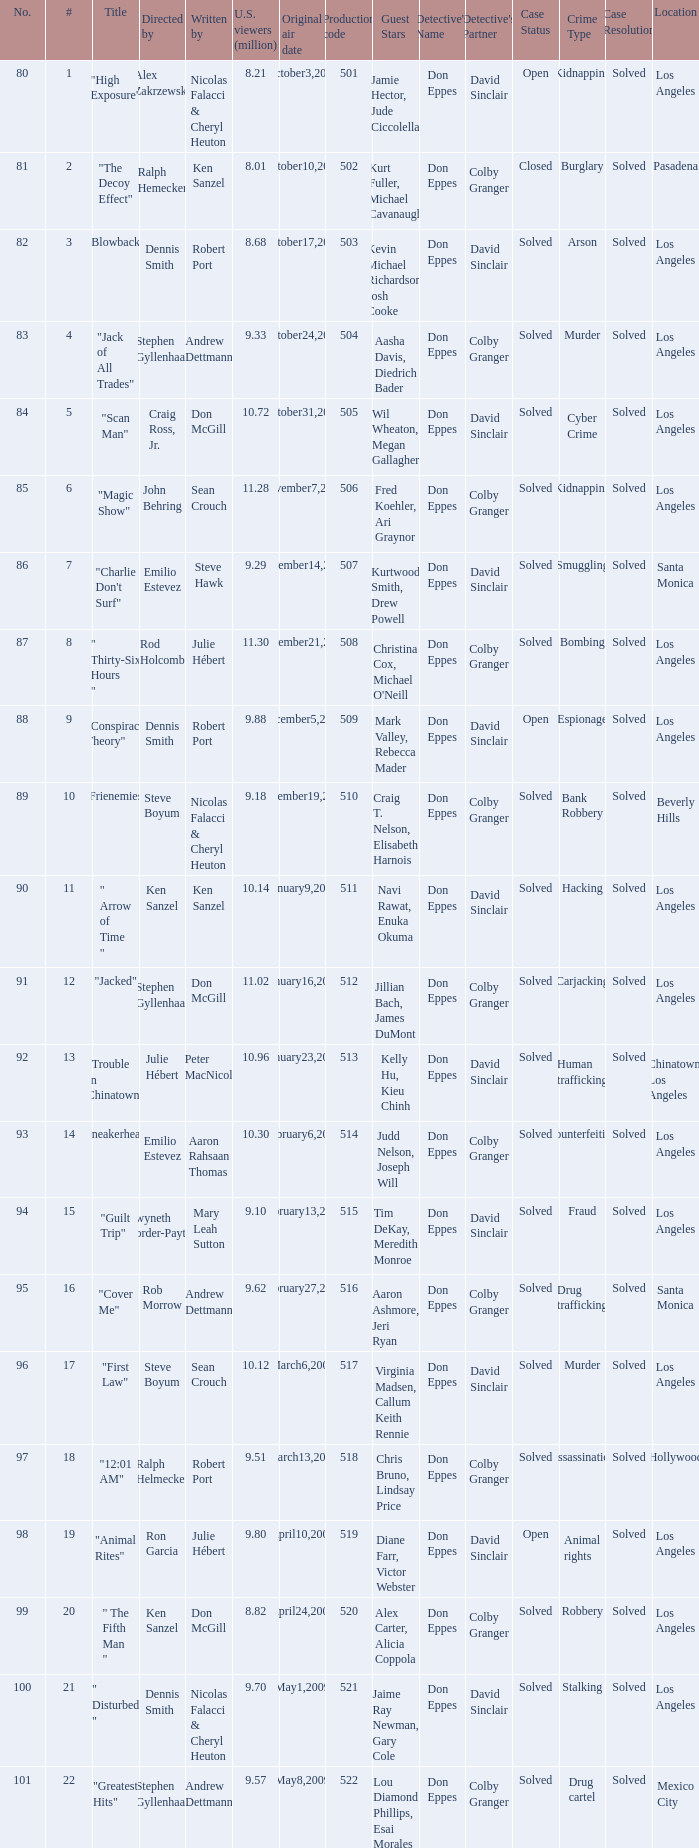What episode number was directed by Craig Ross, Jr. 5.0. 